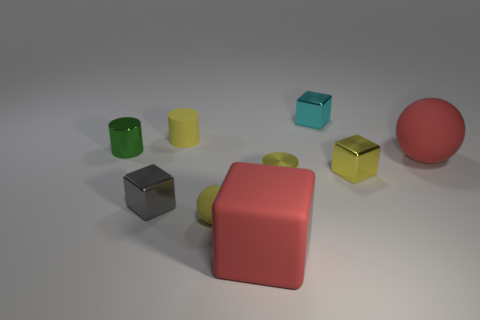Subtract all spheres. How many objects are left? 7 Subtract all small yellow shiny objects. Subtract all small brown rubber objects. How many objects are left? 7 Add 7 green metal things. How many green metal things are left? 8 Add 3 tiny yellow cylinders. How many tiny yellow cylinders exist? 5 Subtract 0 gray cylinders. How many objects are left? 9 